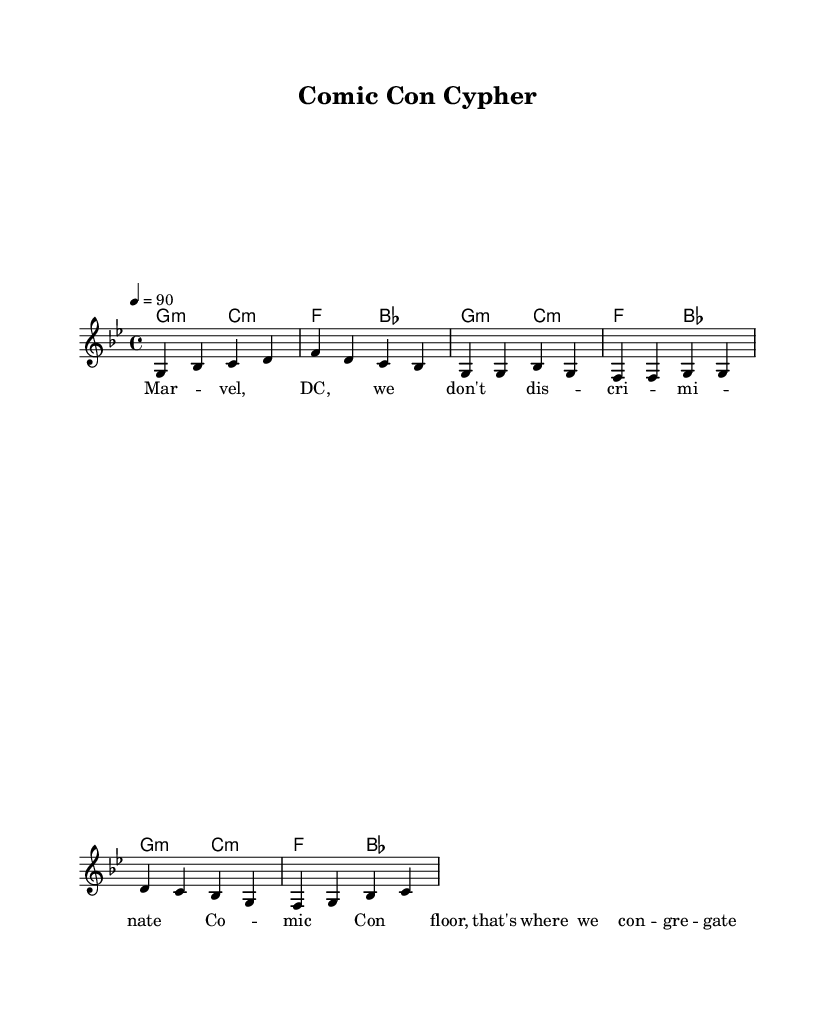what is the key signature of this music? The key signature is G minor, which has two flats (B flat and E flat). This can be determined by looking for the flats indicated at the beginning of the staff.
Answer: G minor what is the time signature of this music? The time signature is 4/4, which is indicated at the beginning of the score. This means there are four beats in each measure and the quarter note receives one beat.
Answer: 4/4 what is the tempo marking for this piece? The tempo marking is 90, as indicated by the text "4 = 90" below the tempo indication. This means the piece should be played at 90 beats per minute.
Answer: 90 how many measures are in the melody section? The melody section consists of 8 measures, counted by the vertical lines that separate each measure in the notation.
Answer: 8 measures what is the first lyric phrase in the song? The first lyric phrase is "Mar - vel, DC, we don't dis - cri - mi - nate," which can be identified directly from the lyrics under the melody staff.
Answer: "Mar - vel, DC, we don't dis - cri - mi - nate." which chord is used in the first measure? The chord used in the first measure is G minor, which can be identified at the beginning of the score in the harmonies section.
Answer: G minor why is the song categorized as Hip Hop? The song is categorized as Hip Hop due to its themes celebrating comic books, movies, and pop culture, conveyed through a rhythmic and lyrical structure characteristic of the genre.
Answer: Celebrating comic books and pop culture 